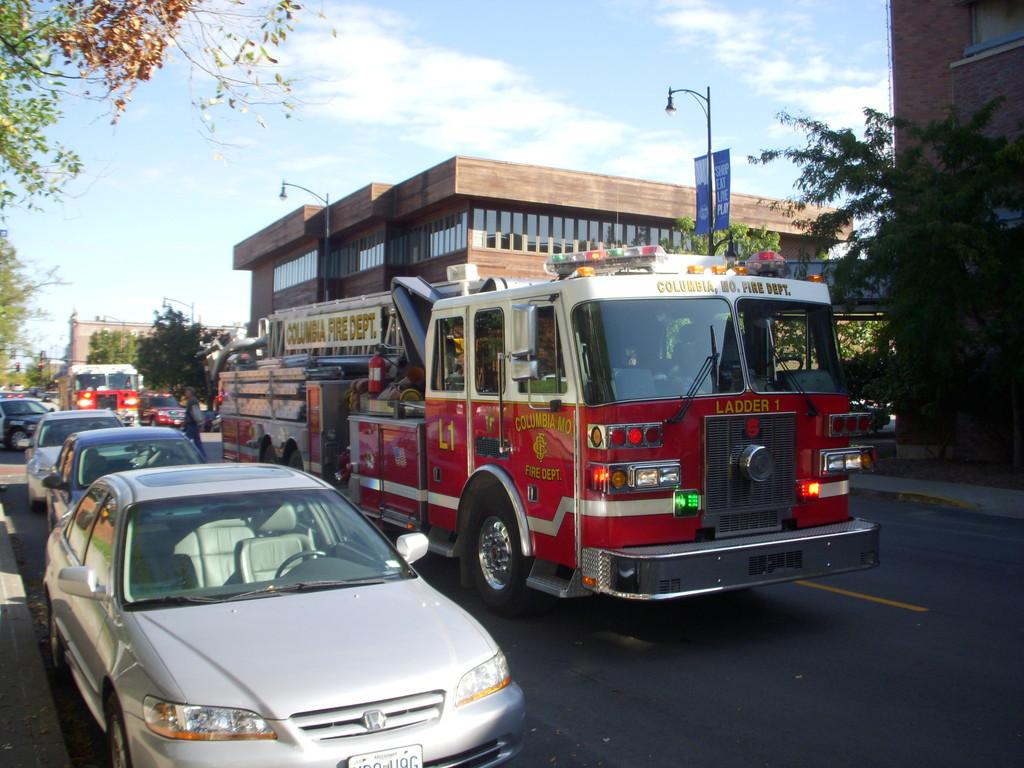What can be seen on the road in the image? There are vehicles on the road in the image. What is visible in the background of the image? There are trees, poles, buildings, and windows visible in the background. Can you describe the board on a pole in the image? There is a small board on a pole in the image. What is the condition of the sky in the image? Clouds are visible in the sky in the image. What type of crime is being committed in the image? There is no indication of any crime being committed in the image. What type of wine is being served at the downtown event in the image? There is no downtown event or wine present in the image. 